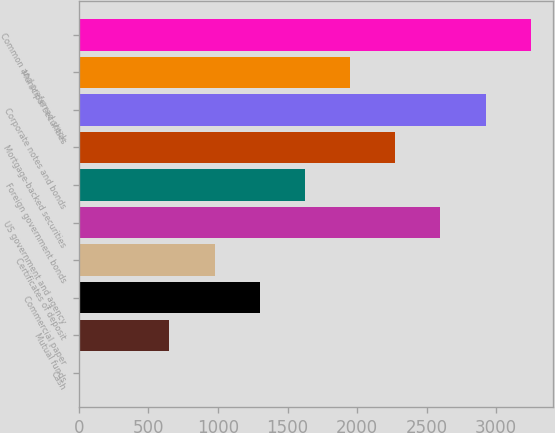<chart> <loc_0><loc_0><loc_500><loc_500><bar_chart><fcel>Cash<fcel>Mutual funds<fcel>Commercial paper<fcel>Certificates of deposit<fcel>US government and agency<fcel>Foreign government bonds<fcel>Mortgage-backed securities<fcel>Corporate notes and bonds<fcel>Municipal securities<fcel>Common and preferred stock<nl><fcel>0.2<fcel>649.96<fcel>1299.72<fcel>974.84<fcel>2599.24<fcel>1624.6<fcel>2274.36<fcel>2924.12<fcel>1949.48<fcel>3249<nl></chart> 